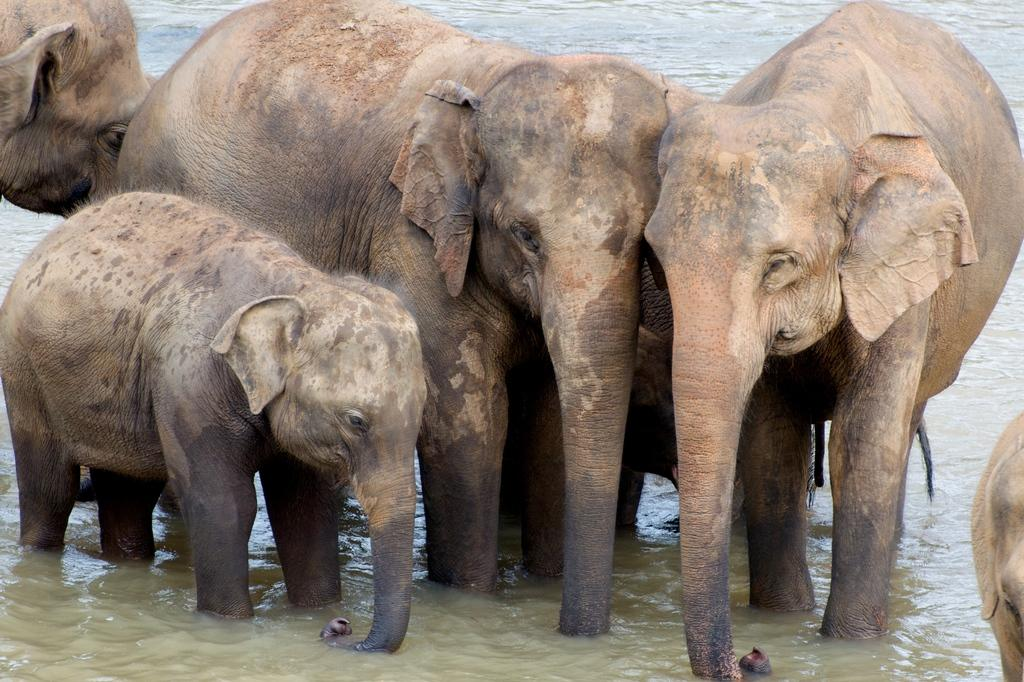What animals can be seen in the image? There are elephants in the image. What body of water is present in the image? There is a lake in the image. Can you tell me how many dinosaurs are swimming in the lake in the image? There are no dinosaurs present in the image; it features elephants and a lake. How are the elephants sorting themselves in the image? The elephants are not sorting themselves in the image; they are simply standing or walking near the lake. 